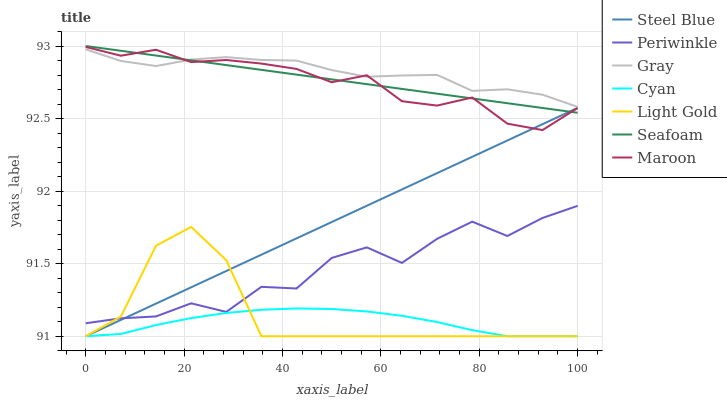Does Cyan have the minimum area under the curve?
Answer yes or no. Yes. Does Gray have the maximum area under the curve?
Answer yes or no. Yes. Does Seafoam have the minimum area under the curve?
Answer yes or no. No. Does Seafoam have the maximum area under the curve?
Answer yes or no. No. Is Seafoam the smoothest?
Answer yes or no. Yes. Is Periwinkle the roughest?
Answer yes or no. Yes. Is Maroon the smoothest?
Answer yes or no. No. Is Maroon the roughest?
Answer yes or no. No. Does Steel Blue have the lowest value?
Answer yes or no. Yes. Does Seafoam have the lowest value?
Answer yes or no. No. Does Seafoam have the highest value?
Answer yes or no. Yes. Does Maroon have the highest value?
Answer yes or no. No. Is Light Gold less than Gray?
Answer yes or no. Yes. Is Gray greater than Steel Blue?
Answer yes or no. Yes. Does Steel Blue intersect Periwinkle?
Answer yes or no. Yes. Is Steel Blue less than Periwinkle?
Answer yes or no. No. Is Steel Blue greater than Periwinkle?
Answer yes or no. No. Does Light Gold intersect Gray?
Answer yes or no. No. 